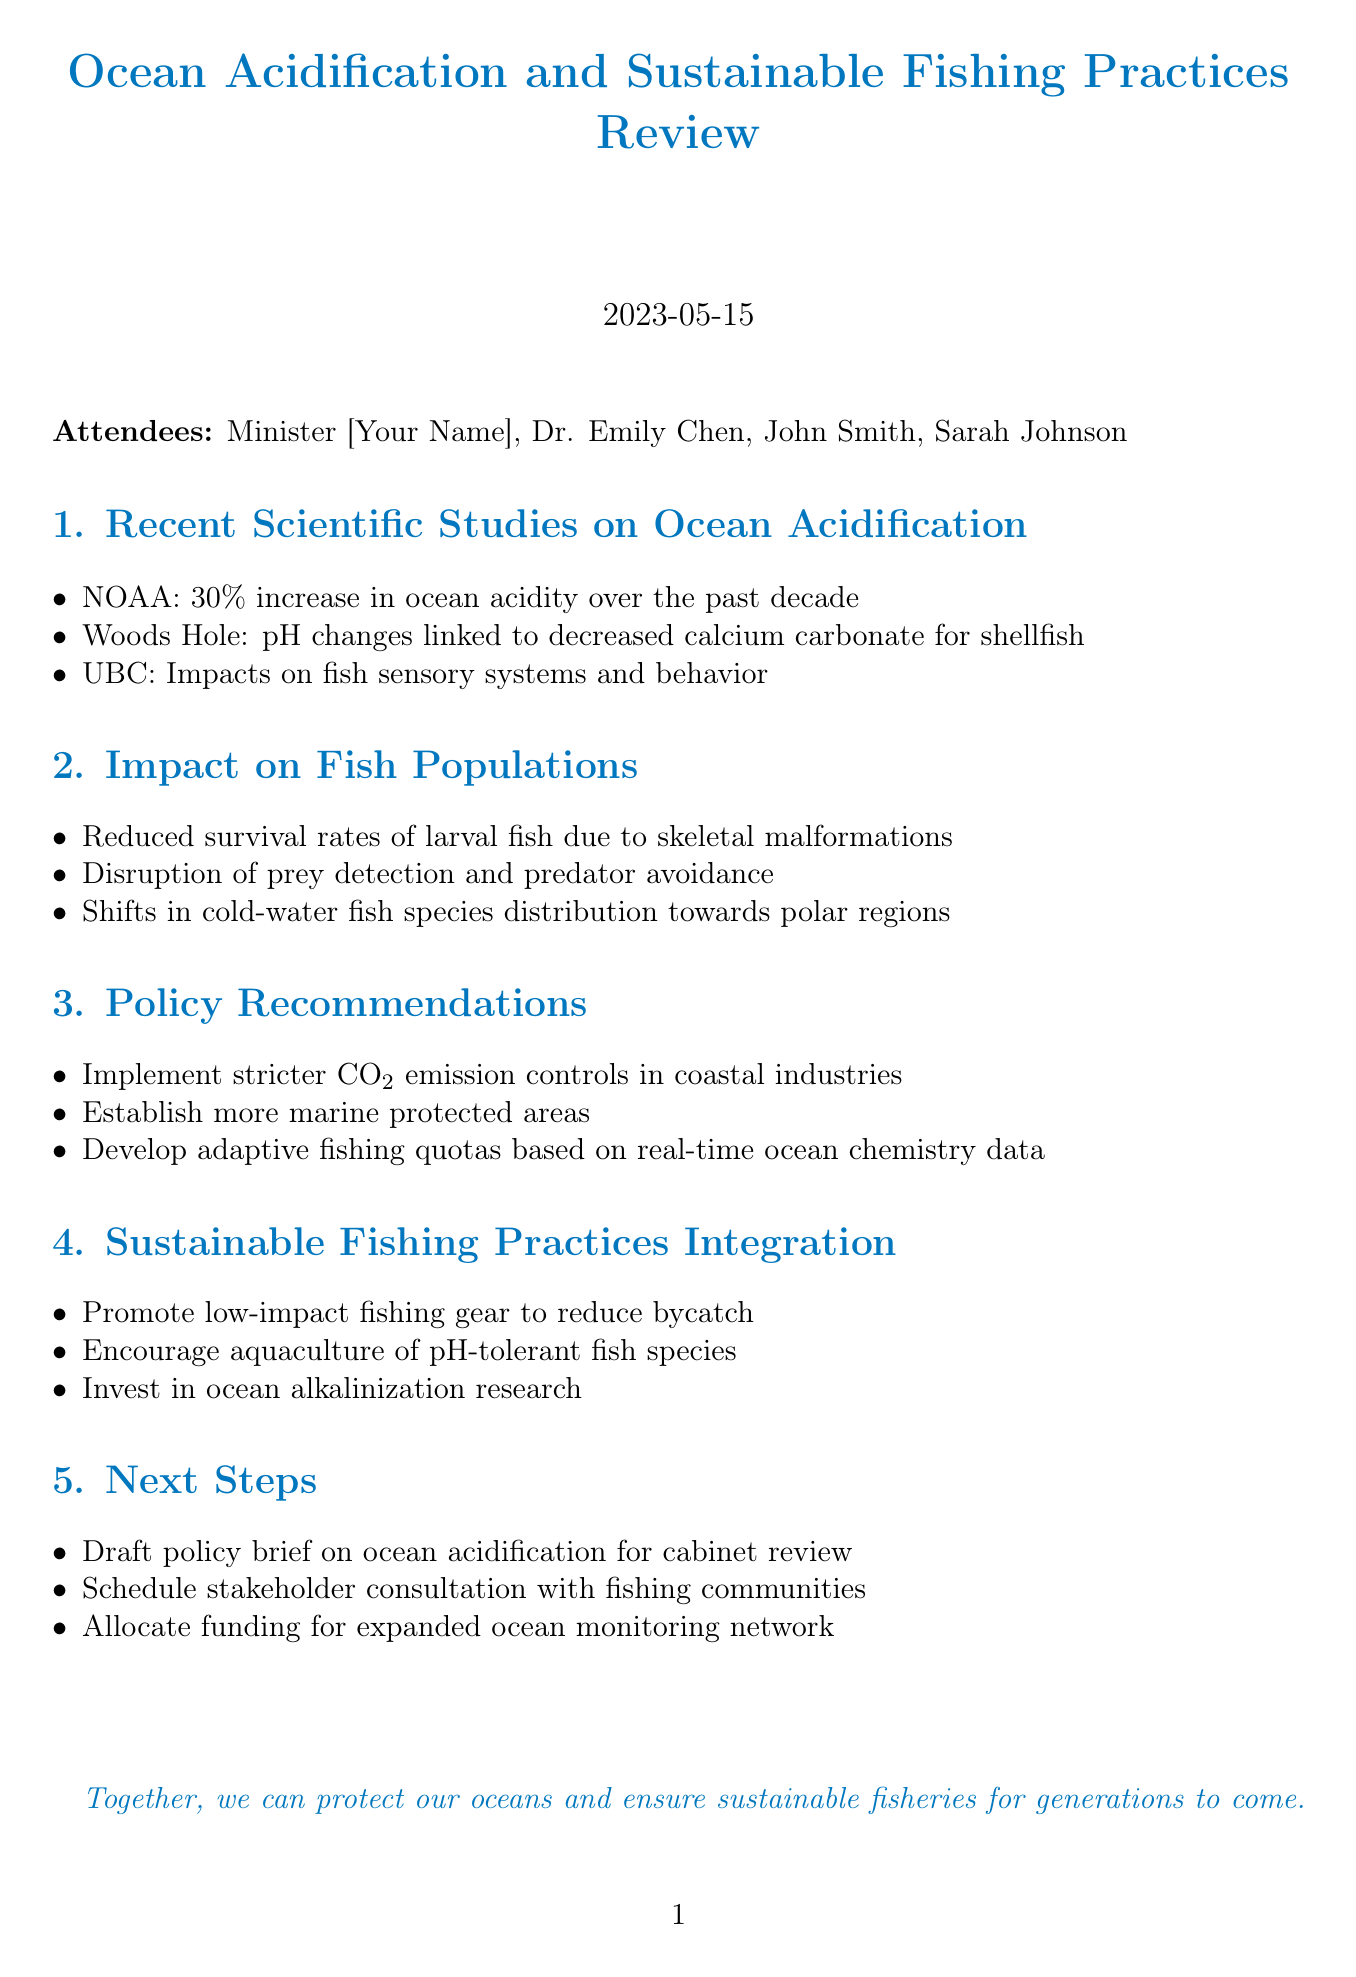What is the date of the meeting? The date is specified in the document heading.
Answer: 2023-05-15 Who is the marine biologist present at the meeting? The attendees' section lists all participants, including their designations.
Answer: Dr. Emily Chen What percentage increase in ocean acidity did NOAA report? This information is provided in the key points under recent scientific studies.
Answer: 30% What is one impact of ocean acidification on fish populations? The impact section lists specific consequences of ocean acidification on fish.
Answer: Reduced survival rates of larval fish What is one policy recommendation at the meeting? The policy recommendations section outlines proposed actions related to ocean acidification.
Answer: Implement stricter CO2 emission controls What type of fishing gear is promoted for sustainable fishing practices? The sustainable fishing practices integration section specifies the gear type.
Answer: low-impact fishing gear What will be drafted for the cabinet review? The next steps section outlines the actions to be taken following the meeting.
Answer: policy brief on ocean acidification How many attendees were present at the meeting? The attendees' section lists the participants present.
Answer: Four 